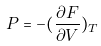<formula> <loc_0><loc_0><loc_500><loc_500>P = - ( \frac { \partial F } { \partial V } ) _ { T }</formula> 